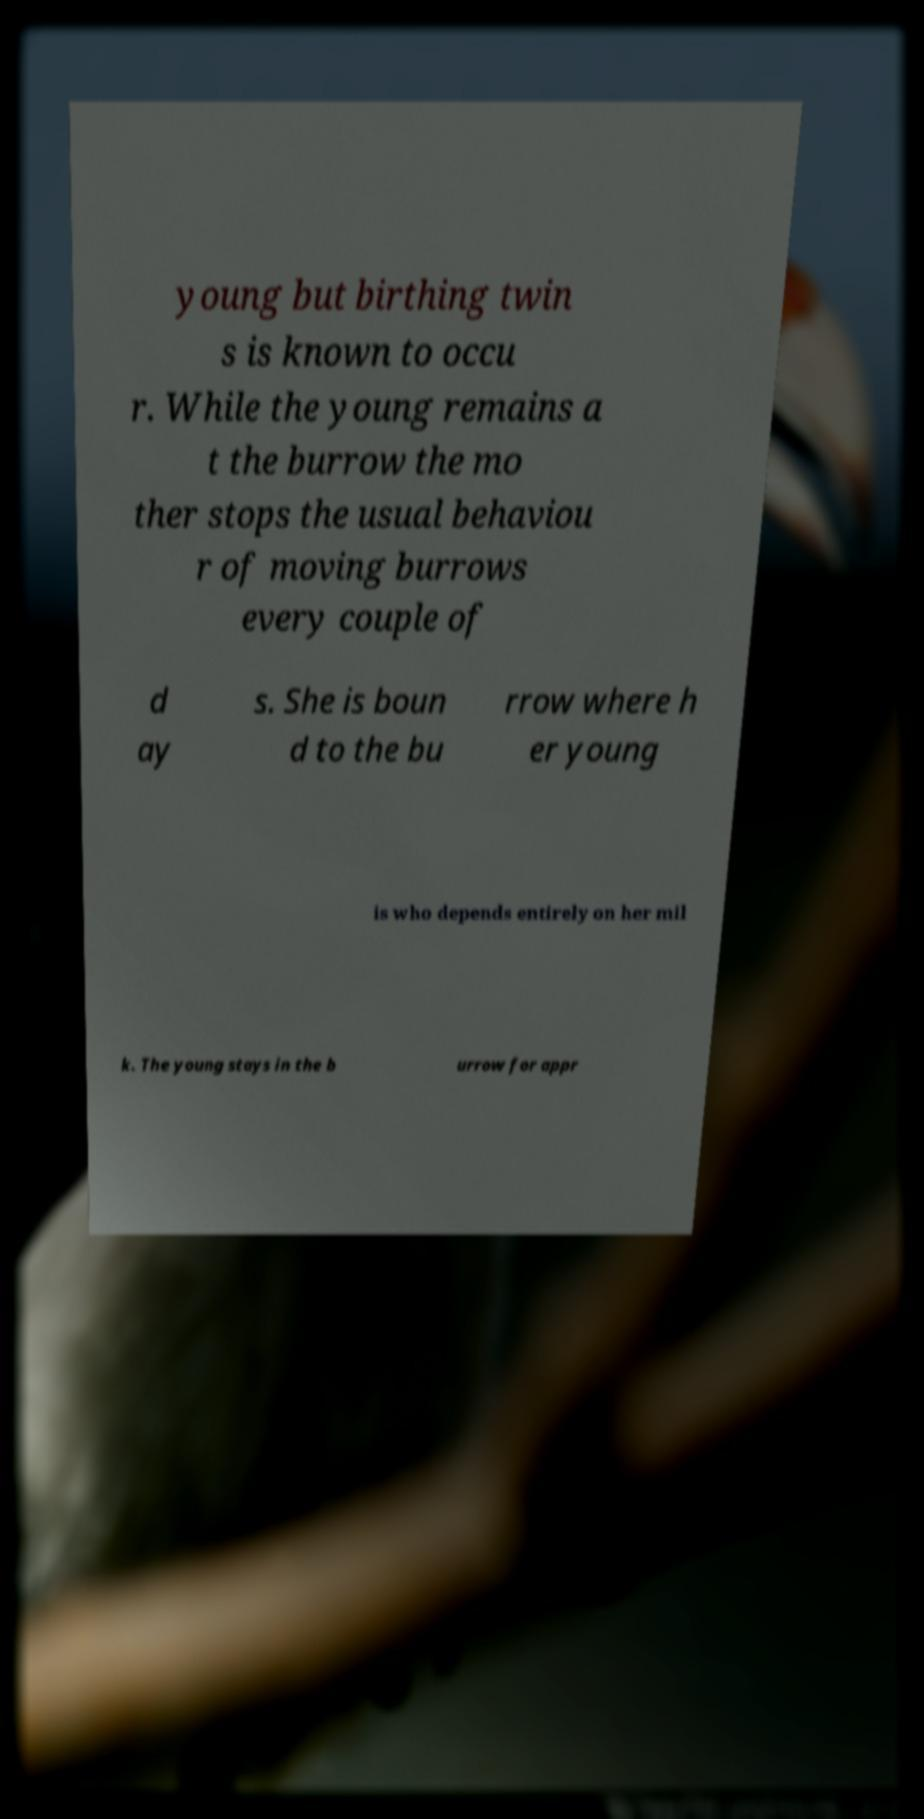For documentation purposes, I need the text within this image transcribed. Could you provide that? young but birthing twin s is known to occu r. While the young remains a t the burrow the mo ther stops the usual behaviou r of moving burrows every couple of d ay s. She is boun d to the bu rrow where h er young is who depends entirely on her mil k. The young stays in the b urrow for appr 